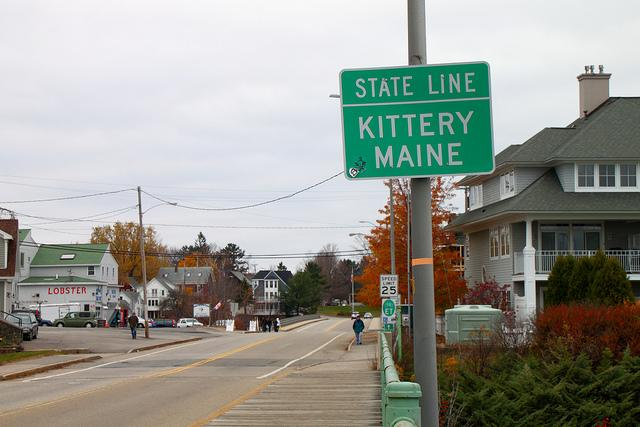What large body of water is nearest this location?

Choices:
A) arctic ocean
B) atlantic ocean
C) amazon river
D) mississippi river atlantic ocean 